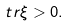Convert formula to latex. <formula><loc_0><loc_0><loc_500><loc_500>\ t r \xi > 0 .</formula> 